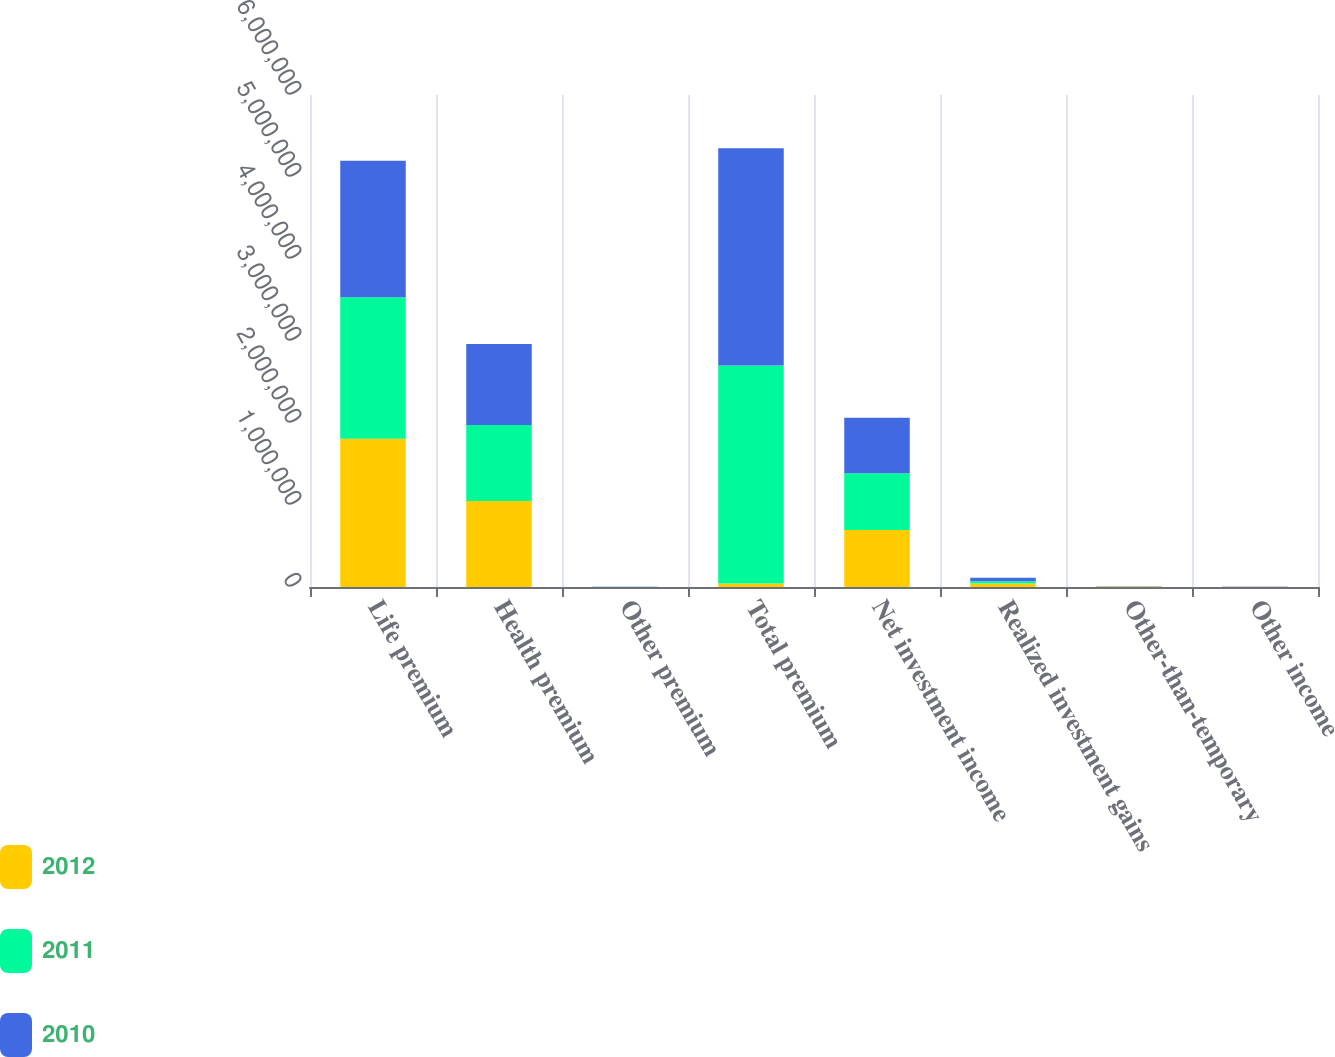Convert chart to OTSL. <chart><loc_0><loc_0><loc_500><loc_500><stacked_bar_chart><ecel><fcel>Life premium<fcel>Health premium<fcel>Other premium<fcel>Total premium<fcel>Net investment income<fcel>Realized investment gains<fcel>Other-than-temporary<fcel>Other income<nl><fcel>2012<fcel>1.80852e+06<fcel>1.04738e+06<fcel>559<fcel>43433<fcel>693644<fcel>43433<fcel>5600<fcel>1577<nl><fcel>2011<fcel>1.72624e+06<fcel>929466<fcel>608<fcel>2.65632e+06<fcel>693028<fcel>25924<fcel>20<fcel>2151<nl><fcel>2010<fcel>1.6637e+06<fcel>987421<fcel>638<fcel>2.65176e+06<fcel>676364<fcel>42190<fcel>4850<fcel>2170<nl></chart> 